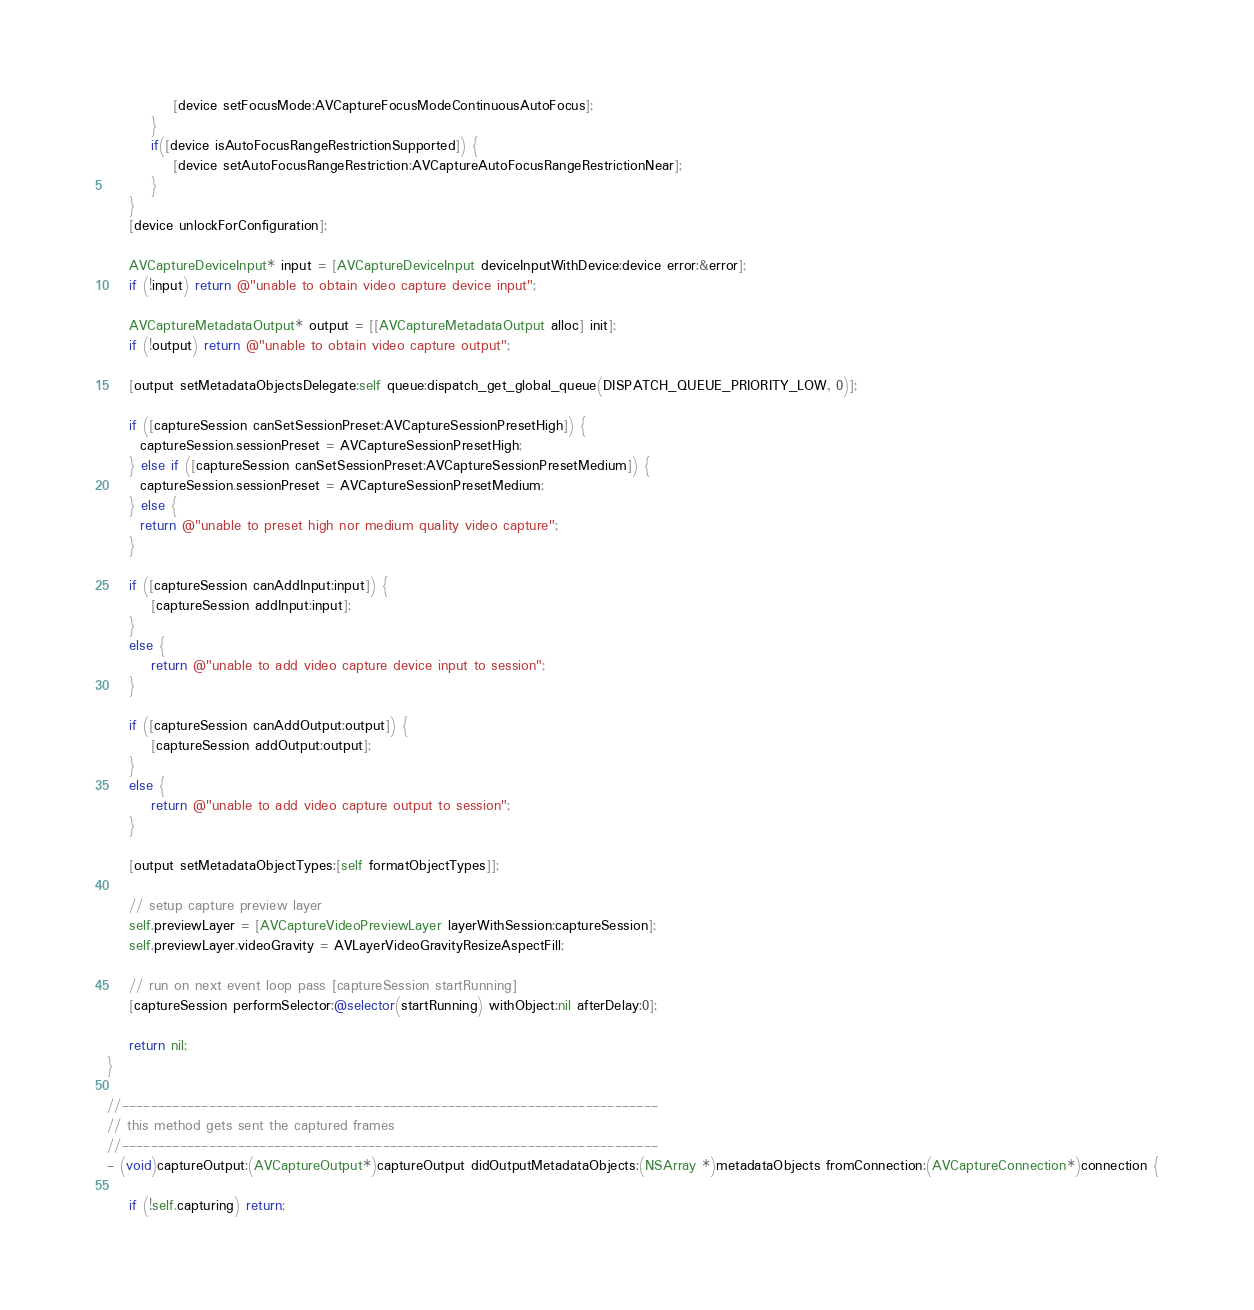Convert code to text. <code><loc_0><loc_0><loc_500><loc_500><_ObjectiveC_>            [device setFocusMode:AVCaptureFocusModeContinuousAutoFocus];
        }
        if([device isAutoFocusRangeRestrictionSupported]) {
            [device setAutoFocusRangeRestriction:AVCaptureAutoFocusRangeRestrictionNear];
        }
    }
    [device unlockForConfiguration];

    AVCaptureDeviceInput* input = [AVCaptureDeviceInput deviceInputWithDevice:device error:&error];
    if (!input) return @"unable to obtain video capture device input";

    AVCaptureMetadataOutput* output = [[AVCaptureMetadataOutput alloc] init];
    if (!output) return @"unable to obtain video capture output";

    [output setMetadataObjectsDelegate:self queue:dispatch_get_global_queue(DISPATCH_QUEUE_PRIORITY_LOW, 0)];

    if ([captureSession canSetSessionPreset:AVCaptureSessionPresetHigh]) {
      captureSession.sessionPreset = AVCaptureSessionPresetHigh;
    } else if ([captureSession canSetSessionPreset:AVCaptureSessionPresetMedium]) {
      captureSession.sessionPreset = AVCaptureSessionPresetMedium;
    } else {
      return @"unable to preset high nor medium quality video capture";
    }

    if ([captureSession canAddInput:input]) {
        [captureSession addInput:input];
    }
    else {
        return @"unable to add video capture device input to session";
    }

    if ([captureSession canAddOutput:output]) {
        [captureSession addOutput:output];
    }
    else {
        return @"unable to add video capture output to session";
    }

    [output setMetadataObjectTypes:[self formatObjectTypes]];

    // setup capture preview layer
    self.previewLayer = [AVCaptureVideoPreviewLayer layerWithSession:captureSession];
    self.previewLayer.videoGravity = AVLayerVideoGravityResizeAspectFill;

    // run on next event loop pass [captureSession startRunning]
    [captureSession performSelector:@selector(startRunning) withObject:nil afterDelay:0];

    return nil;
}

//--------------------------------------------------------------------------
// this method gets sent the captured frames
//--------------------------------------------------------------------------
- (void)captureOutput:(AVCaptureOutput*)captureOutput didOutputMetadataObjects:(NSArray *)metadataObjects fromConnection:(AVCaptureConnection*)connection {

    if (!self.capturing) return;
</code> 